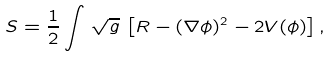<formula> <loc_0><loc_0><loc_500><loc_500>S = \frac { 1 } { 2 } \int \, \sqrt { g } \, \left [ R - ( \nabla \phi ) ^ { 2 } - 2 V ( \phi ) \right ] ,</formula> 